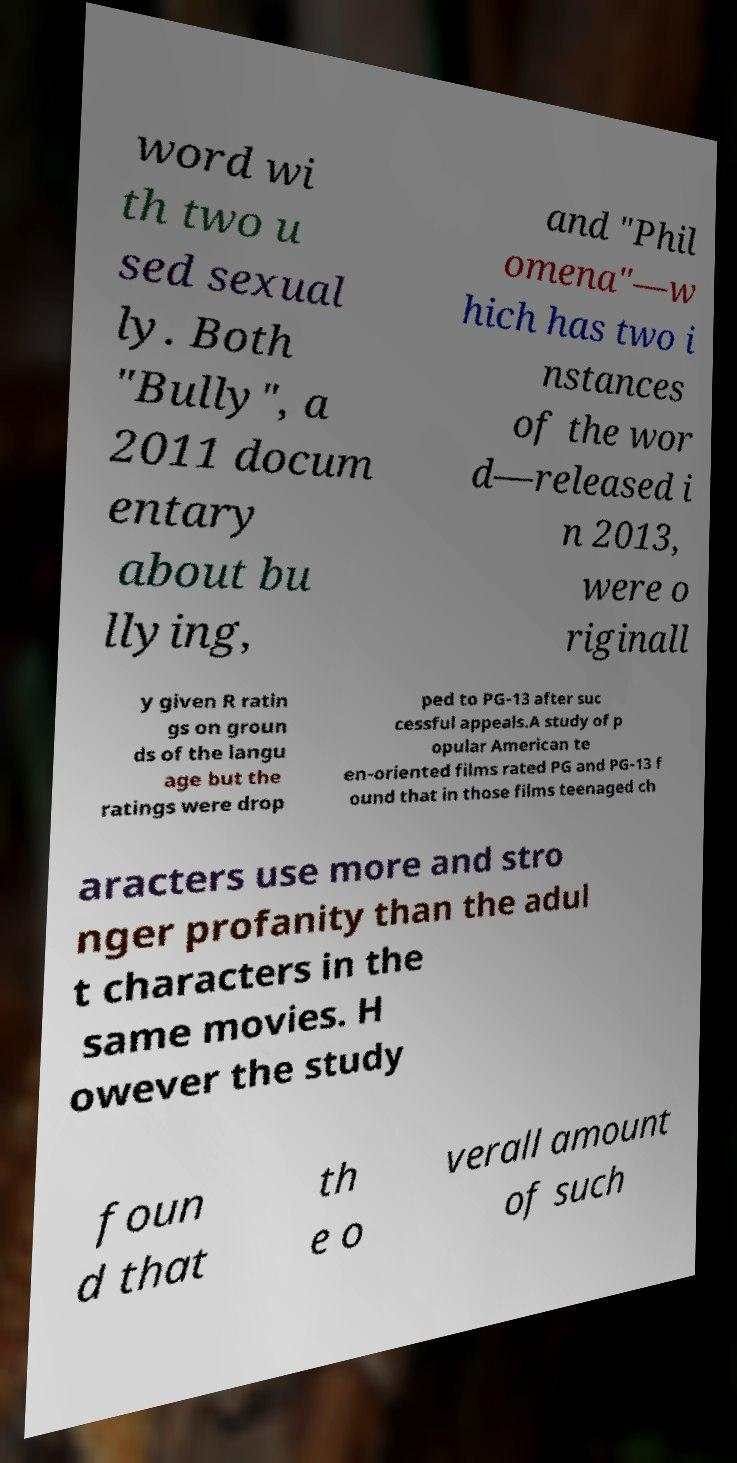What messages or text are displayed in this image? I need them in a readable, typed format. word wi th two u sed sexual ly. Both "Bully", a 2011 docum entary about bu llying, and "Phil omena"—w hich has two i nstances of the wor d—released i n 2013, were o riginall y given R ratin gs on groun ds of the langu age but the ratings were drop ped to PG-13 after suc cessful appeals.A study of p opular American te en-oriented films rated PG and PG-13 f ound that in those films teenaged ch aracters use more and stro nger profanity than the adul t characters in the same movies. H owever the study foun d that th e o verall amount of such 